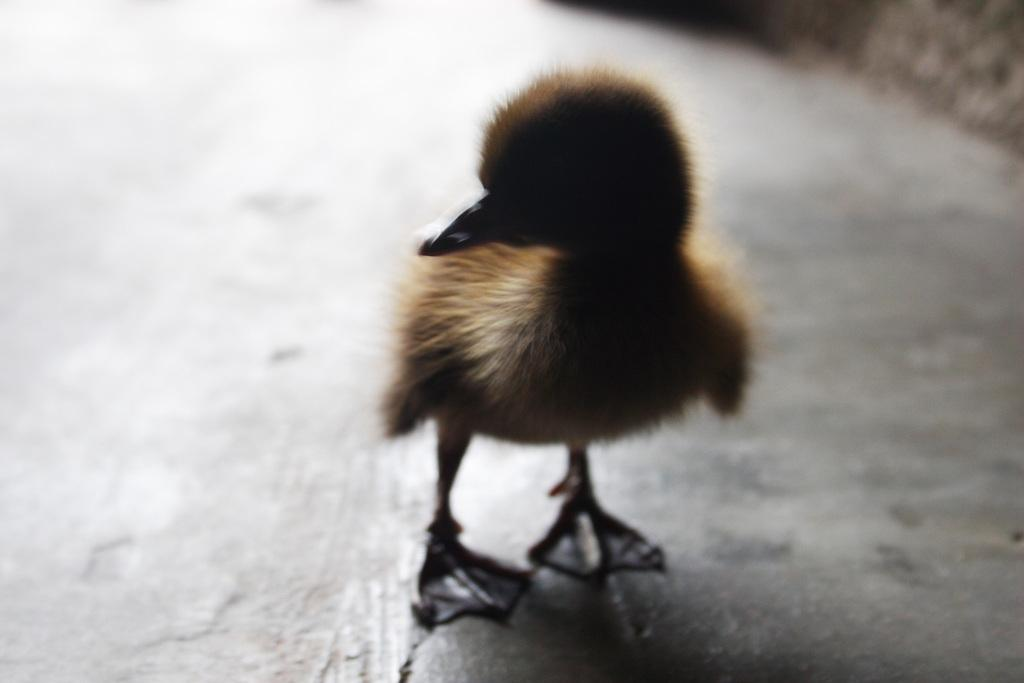What type of animal is in the image? There is a chick in the image. Where is the chick located? The chick is on the ground. How many spiders are crawling on the chick in the image? There are no spiders present in the image; it only features a chick on the ground. What type of boot is visible in the image? There is no boot present in the image. 